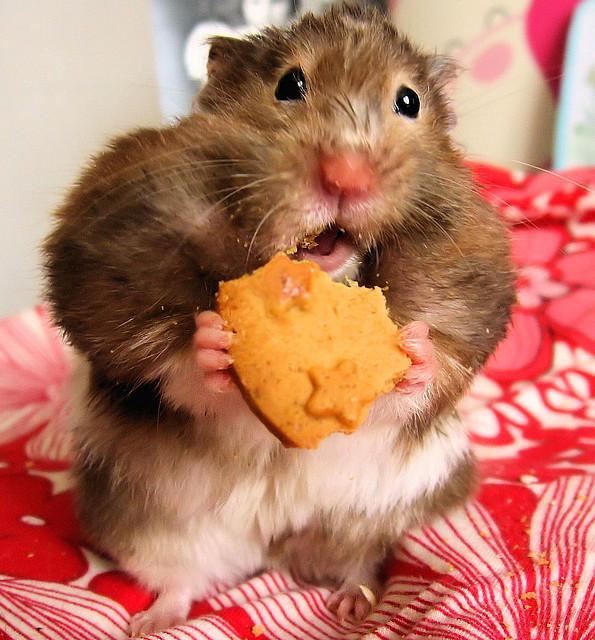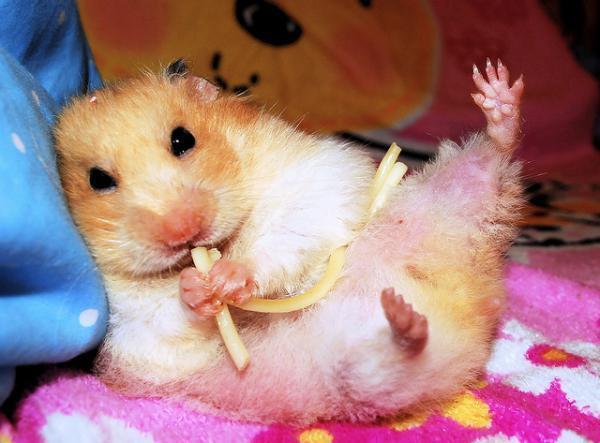The first image is the image on the left, the second image is the image on the right. Analyze the images presented: Is the assertion "The hamster on the left grasps a square treat ready to munch." valid? Answer yes or no. Yes. 